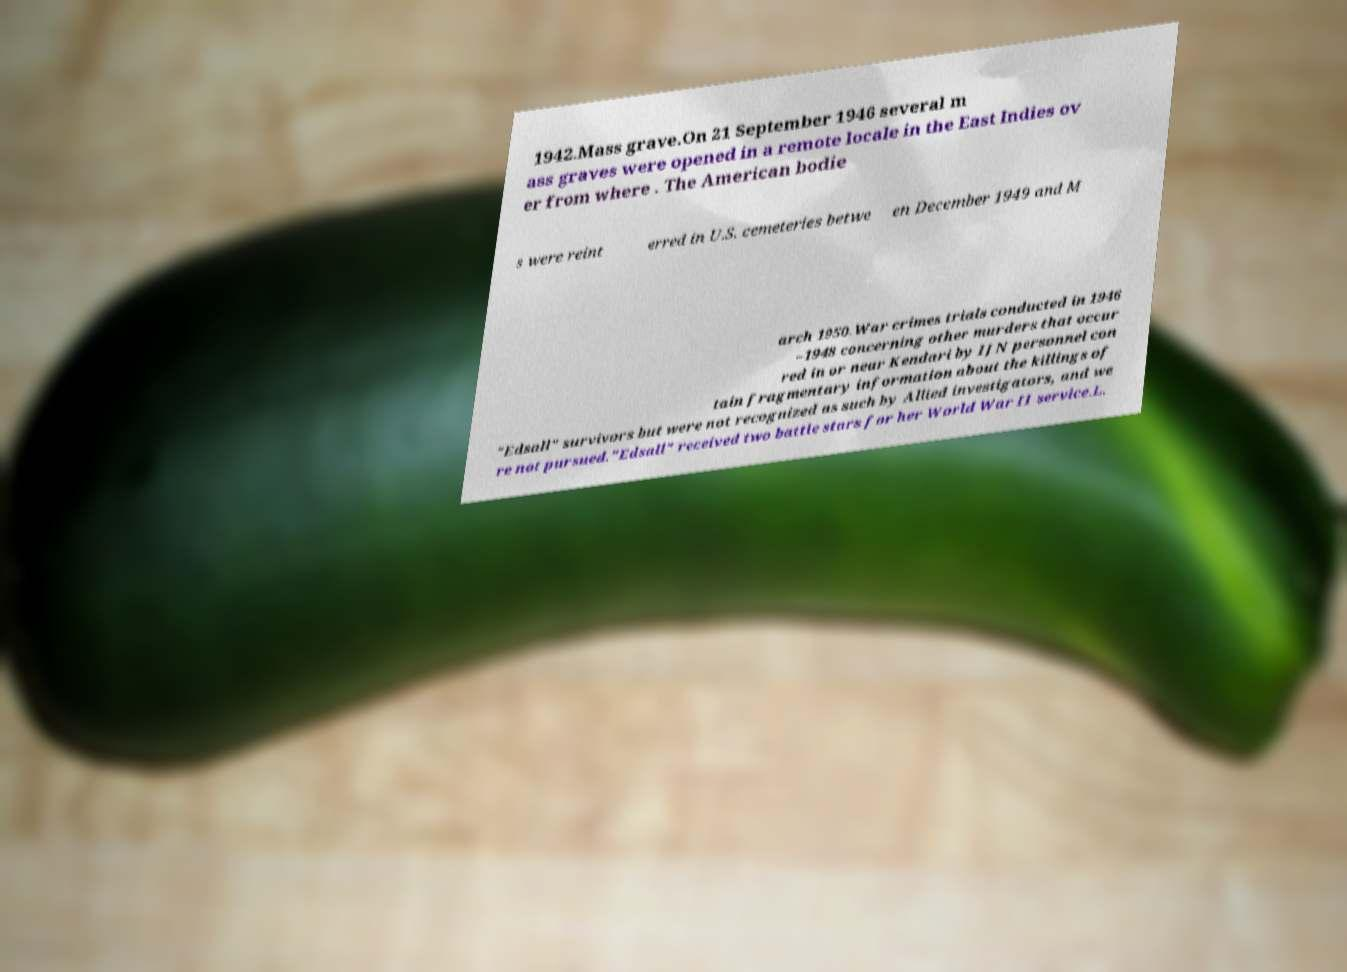Please read and relay the text visible in this image. What does it say? 1942.Mass grave.On 21 September 1946 several m ass graves were opened in a remote locale in the East Indies ov er from where . The American bodie s were reint erred in U.S. cemeteries betwe en December 1949 and M arch 1950.War crimes trials conducted in 1946 –1948 concerning other murders that occur red in or near Kendari by IJN personnel con tain fragmentary information about the killings of "Edsall" survivors but were not recognized as such by Allied investigators, and we re not pursued."Edsall" received two battle stars for her World War II service.L. 